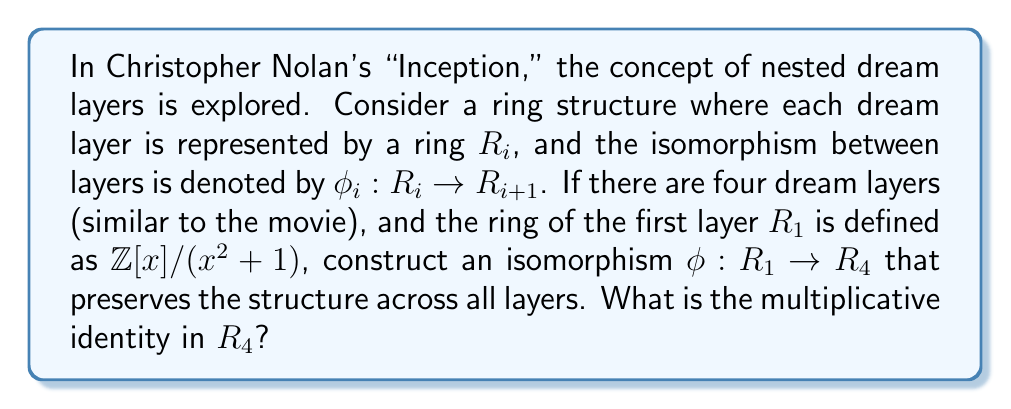Solve this math problem. Let's approach this step-by-step:

1) First, we need to understand what $R_1 = \mathbb{Z}[x]/(x^2+1)$ means. This is the ring of polynomials with integer coefficients modulo $x^2+1$. It's isomorphic to the complex numbers $\mathbb{C}$.

2) For the isomorphism to preserve structure across all layers, each $R_i$ must be isomorphic to $R_1$. So, $R_2$, $R_3$, and $R_4$ are all isomorphic to $\mathbb{C}$.

3) We need to construct $\phi: R_1 \rightarrow R_4$. This can be done by composing the isomorphisms between consecutive layers:

   $\phi = \phi_3 \circ \phi_2 \circ \phi_1$

4) Each $\phi_i$ must map the generators of $R_i$ to the generators of $R_{i+1}$. In $R_1$, the generators are $1$ and $i$ (where $i^2 = -1$).

5) One possible isomorphism that preserves the ring structure is:

   $\phi_1(a + bi) = a + bi$
   $\phi_2(a + bi) = a - bi$
   $\phi_3(a + bi) = a + bi$

6) Composing these:

   $\phi(a + bi) = \phi_3(\phi_2(\phi_1(a + bi))) = \phi_3(\phi_2(a + bi)) = \phi_3(a - bi) = a - bi$

7) The multiplicative identity in any ring is always mapped to the multiplicative identity. In $R_1$, the multiplicative identity is 1.

8) Therefore, in $R_4$, the multiplicative identity is $\phi(1) = 1$.
Answer: The multiplicative identity in $R_4$ is 1. 